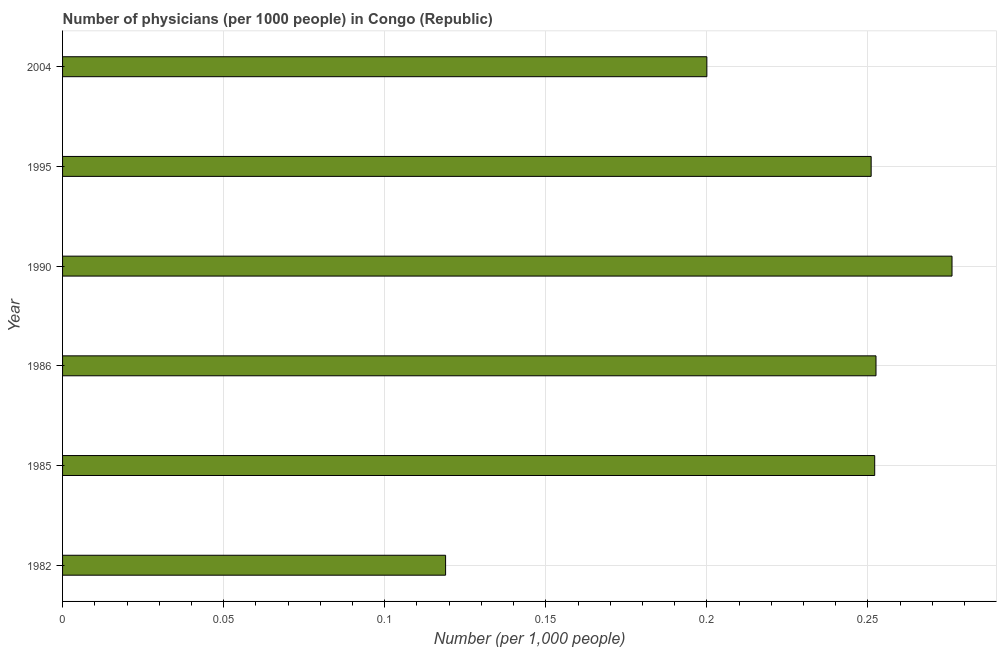What is the title of the graph?
Make the answer very short. Number of physicians (per 1000 people) in Congo (Republic). What is the label or title of the X-axis?
Give a very brief answer. Number (per 1,0 people). What is the number of physicians in 1995?
Your answer should be very brief. 0.25. Across all years, what is the maximum number of physicians?
Ensure brevity in your answer.  0.28. Across all years, what is the minimum number of physicians?
Keep it short and to the point. 0.12. In which year was the number of physicians minimum?
Make the answer very short. 1982. What is the sum of the number of physicians?
Your response must be concise. 1.35. What is the difference between the number of physicians in 1986 and 2004?
Offer a terse response. 0.05. What is the average number of physicians per year?
Give a very brief answer. 0.23. What is the median number of physicians?
Your answer should be compact. 0.25. What is the ratio of the number of physicians in 1982 to that in 1986?
Ensure brevity in your answer.  0.47. Is the difference between the number of physicians in 1995 and 2004 greater than the difference between any two years?
Offer a very short reply. No. What is the difference between the highest and the second highest number of physicians?
Make the answer very short. 0.02. What is the difference between the highest and the lowest number of physicians?
Your response must be concise. 0.16. How many bars are there?
Provide a succinct answer. 6. How many years are there in the graph?
Give a very brief answer. 6. What is the difference between two consecutive major ticks on the X-axis?
Your response must be concise. 0.05. Are the values on the major ticks of X-axis written in scientific E-notation?
Your answer should be very brief. No. What is the Number (per 1,000 people) of 1982?
Keep it short and to the point. 0.12. What is the Number (per 1,000 people) in 1985?
Your answer should be compact. 0.25. What is the Number (per 1,000 people) in 1986?
Keep it short and to the point. 0.25. What is the Number (per 1,000 people) in 1990?
Ensure brevity in your answer.  0.28. What is the Number (per 1,000 people) in 1995?
Your response must be concise. 0.25. What is the difference between the Number (per 1,000 people) in 1982 and 1985?
Offer a terse response. -0.13. What is the difference between the Number (per 1,000 people) in 1982 and 1986?
Offer a very short reply. -0.13. What is the difference between the Number (per 1,000 people) in 1982 and 1990?
Give a very brief answer. -0.16. What is the difference between the Number (per 1,000 people) in 1982 and 1995?
Your answer should be very brief. -0.13. What is the difference between the Number (per 1,000 people) in 1982 and 2004?
Provide a short and direct response. -0.08. What is the difference between the Number (per 1,000 people) in 1985 and 1986?
Provide a short and direct response. -0. What is the difference between the Number (per 1,000 people) in 1985 and 1990?
Offer a very short reply. -0.02. What is the difference between the Number (per 1,000 people) in 1985 and 1995?
Offer a very short reply. 0. What is the difference between the Number (per 1,000 people) in 1985 and 2004?
Your answer should be compact. 0.05. What is the difference between the Number (per 1,000 people) in 1986 and 1990?
Offer a terse response. -0.02. What is the difference between the Number (per 1,000 people) in 1986 and 1995?
Provide a short and direct response. 0. What is the difference between the Number (per 1,000 people) in 1986 and 2004?
Provide a short and direct response. 0.05. What is the difference between the Number (per 1,000 people) in 1990 and 1995?
Your answer should be compact. 0.03. What is the difference between the Number (per 1,000 people) in 1990 and 2004?
Offer a very short reply. 0.08. What is the difference between the Number (per 1,000 people) in 1995 and 2004?
Your answer should be very brief. 0.05. What is the ratio of the Number (per 1,000 people) in 1982 to that in 1985?
Your answer should be very brief. 0.47. What is the ratio of the Number (per 1,000 people) in 1982 to that in 1986?
Provide a short and direct response. 0.47. What is the ratio of the Number (per 1,000 people) in 1982 to that in 1990?
Make the answer very short. 0.43. What is the ratio of the Number (per 1,000 people) in 1982 to that in 1995?
Keep it short and to the point. 0.47. What is the ratio of the Number (per 1,000 people) in 1982 to that in 2004?
Provide a succinct answer. 0.59. What is the ratio of the Number (per 1,000 people) in 1985 to that in 1986?
Offer a very short reply. 1. What is the ratio of the Number (per 1,000 people) in 1985 to that in 2004?
Your answer should be compact. 1.26. What is the ratio of the Number (per 1,000 people) in 1986 to that in 1990?
Keep it short and to the point. 0.92. What is the ratio of the Number (per 1,000 people) in 1986 to that in 2004?
Your answer should be compact. 1.26. What is the ratio of the Number (per 1,000 people) in 1990 to that in 1995?
Offer a terse response. 1.1. What is the ratio of the Number (per 1,000 people) in 1990 to that in 2004?
Make the answer very short. 1.38. What is the ratio of the Number (per 1,000 people) in 1995 to that in 2004?
Offer a very short reply. 1.25. 